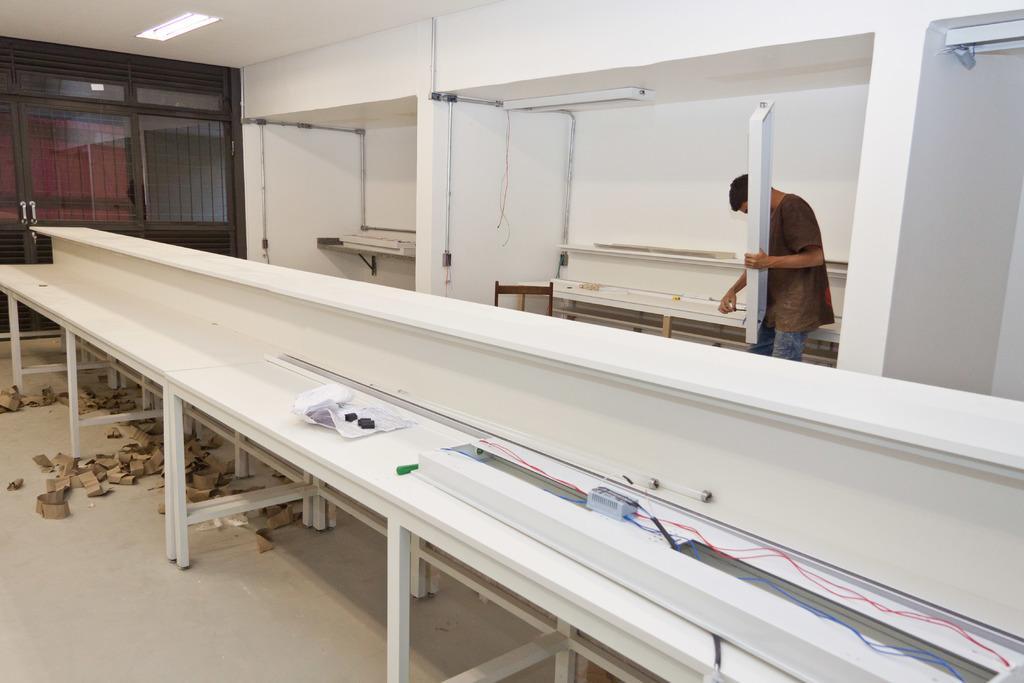Can you describe this image briefly? In this picture I can see tube lights, cables, papers, pen and some other objects on the tables, there are wooden pieces on the floor, there are doors with the door handles, there is a person standing and holding an object, there are pipes, cables, chair and some other items. 